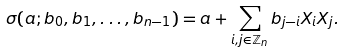Convert formula to latex. <formula><loc_0><loc_0><loc_500><loc_500>\sigma ( a ; b _ { 0 } , b _ { 1 } , \dots , b _ { n - 1 } ) = a + \sum _ { i , j \in \mathbb { Z } _ { n } } b _ { j - i } X _ { i } X _ { j } .</formula> 